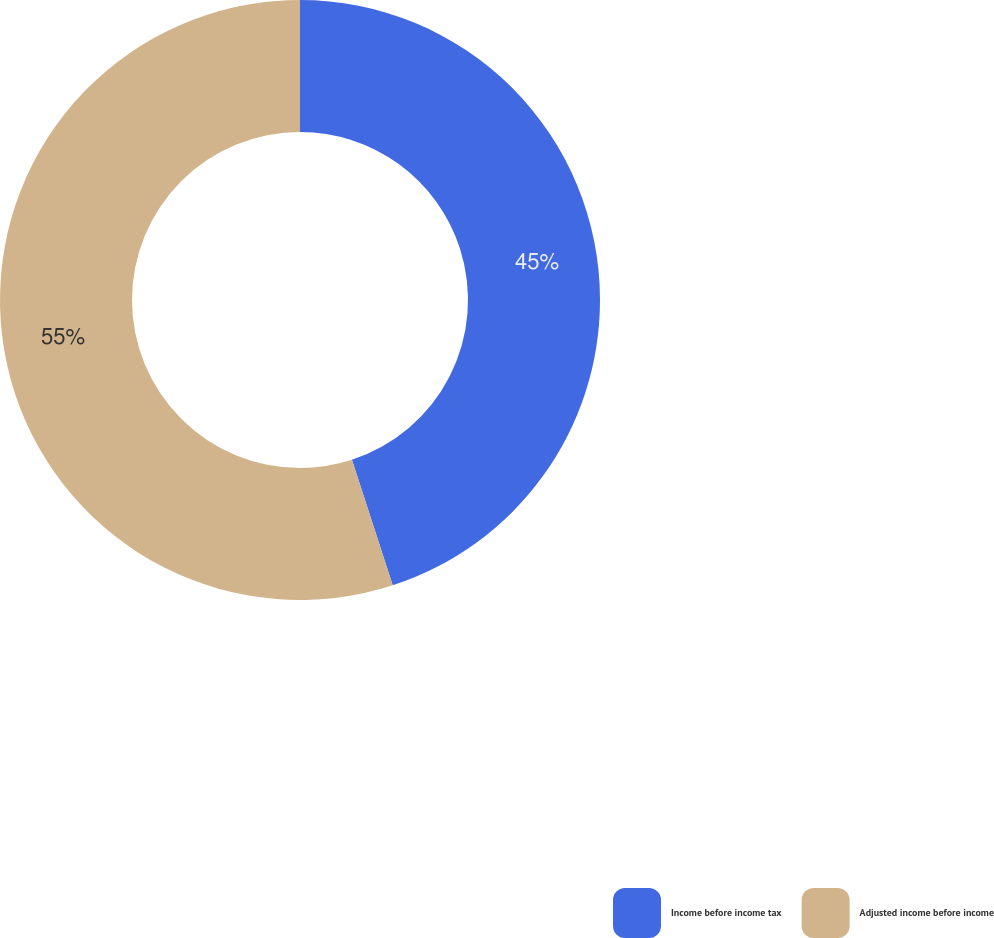Convert chart. <chart><loc_0><loc_0><loc_500><loc_500><pie_chart><fcel>Income before income tax<fcel>Adjusted income before income<nl><fcel>45.0%<fcel>55.0%<nl></chart> 